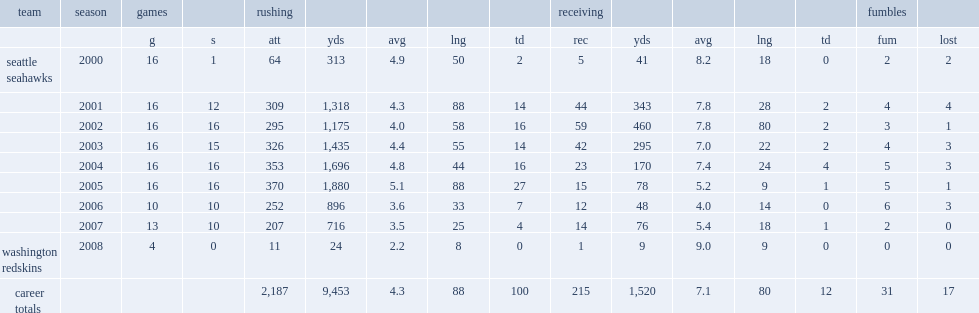How many rushing yards did shaun alexander get in 2004? 1696.0. 